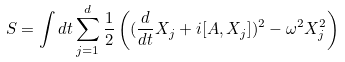<formula> <loc_0><loc_0><loc_500><loc_500>S = \int d t \sum _ { j = 1 } ^ { d } \frac { 1 } { 2 } \left ( ( \frac { d } { d t } X _ { j } + i [ A , X _ { j } ] ) ^ { 2 } - \omega ^ { 2 } X _ { j } ^ { 2 } \right )</formula> 